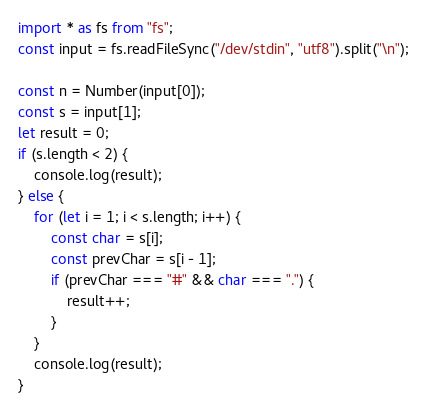<code> <loc_0><loc_0><loc_500><loc_500><_TypeScript_>import * as fs from "fs";
const input = fs.readFileSync("/dev/stdin", "utf8").split("\n");
 
const n = Number(input[0]);
const s = input[1];
let result = 0;
if (s.length < 2) {
    console.log(result);
} else {
    for (let i = 1; i < s.length; i++) {
        const char = s[i];
        const prevChar = s[i - 1];
        if (prevChar === "#" && char === ".") {
            result++;
        }
    }
    console.log(result);
}</code> 